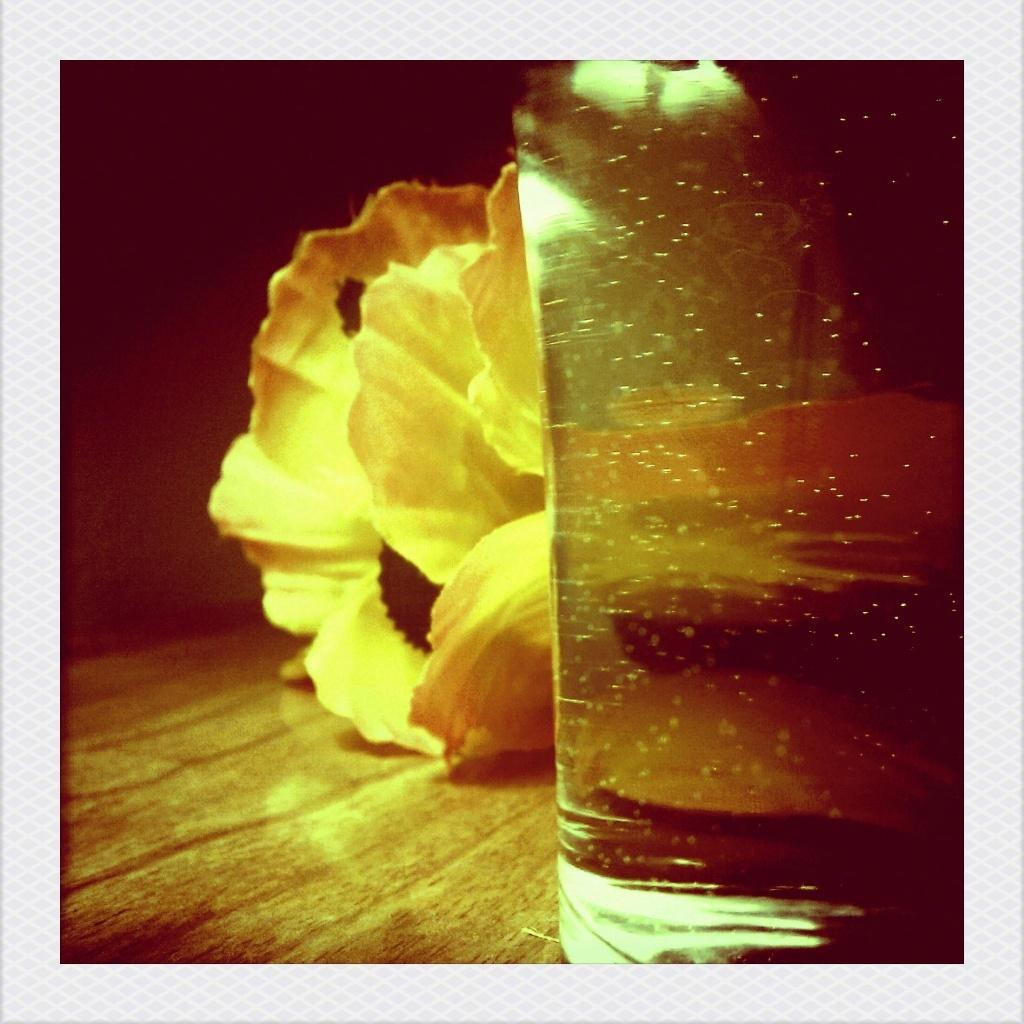What piece of furniture is present in the image? There is a table in the image. What object is placed on the table? There is a glass on the table. What type of decoration is on the table? There are flowers on the table. Where is the river located in the image? There is no river present in the image. What does the mom look like in the image? There is no mention of a mom or any person in the image. 